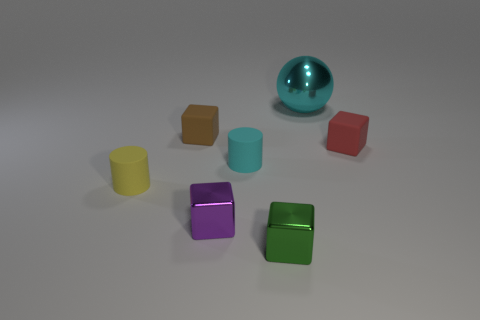Add 2 large brown matte balls. How many objects exist? 9 Subtract all small brown blocks. How many blocks are left? 3 Subtract 1 cylinders. How many cylinders are left? 1 Subtract all cubes. How many objects are left? 3 Add 7 small yellow matte cylinders. How many small yellow matte cylinders are left? 8 Add 6 large yellow matte cubes. How many large yellow matte cubes exist? 6 Subtract all green blocks. How many blocks are left? 3 Subtract 0 yellow spheres. How many objects are left? 7 Subtract all blue cylinders. Subtract all blue balls. How many cylinders are left? 2 Subtract all cyan cylinders. How many green blocks are left? 1 